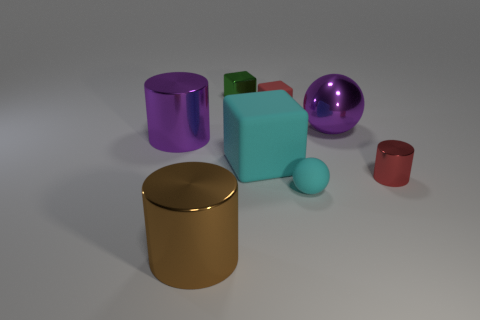The tiny matte sphere has what color? The tiny matte sphere in the image is cyan, providing a subtle contrast against the more reflective and vividly colored objects surrounding it. 